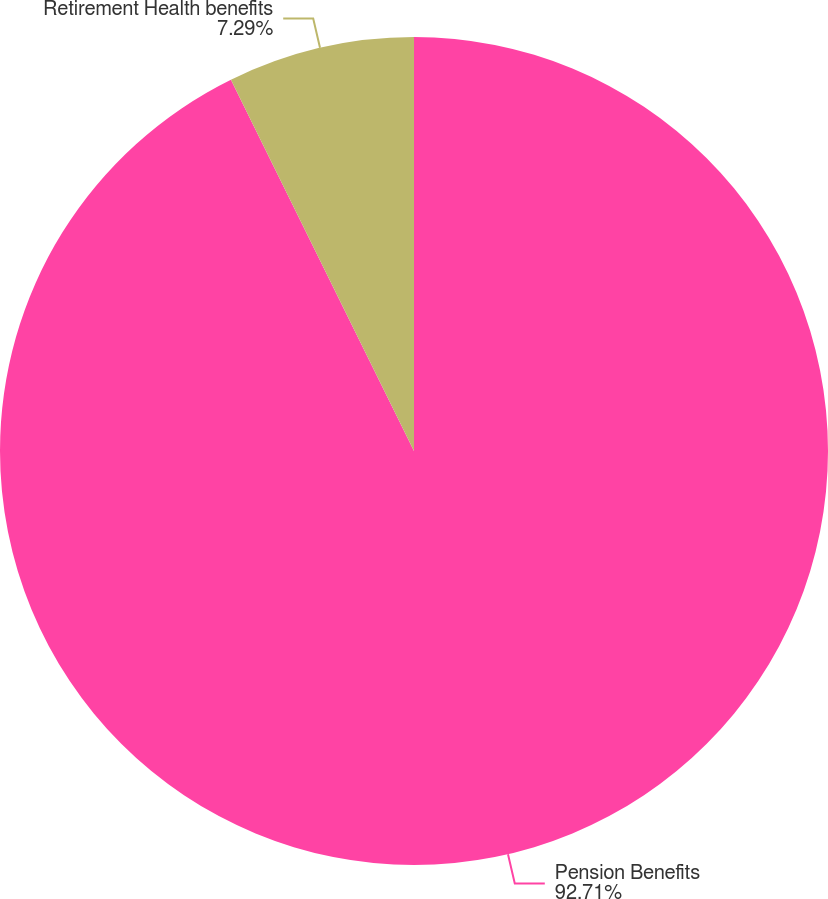<chart> <loc_0><loc_0><loc_500><loc_500><pie_chart><fcel>Pension Benefits<fcel>Retirement Health benefits<nl><fcel>92.71%<fcel>7.29%<nl></chart> 